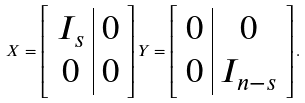Convert formula to latex. <formula><loc_0><loc_0><loc_500><loc_500>X = \left [ \begin{array} { c | c } I _ { s } & 0 \\ 0 & 0 \end{array} \right ] Y = \left [ \begin{array} { c | c } 0 & 0 \\ 0 & I _ { n - s } \end{array} \right ] .</formula> 